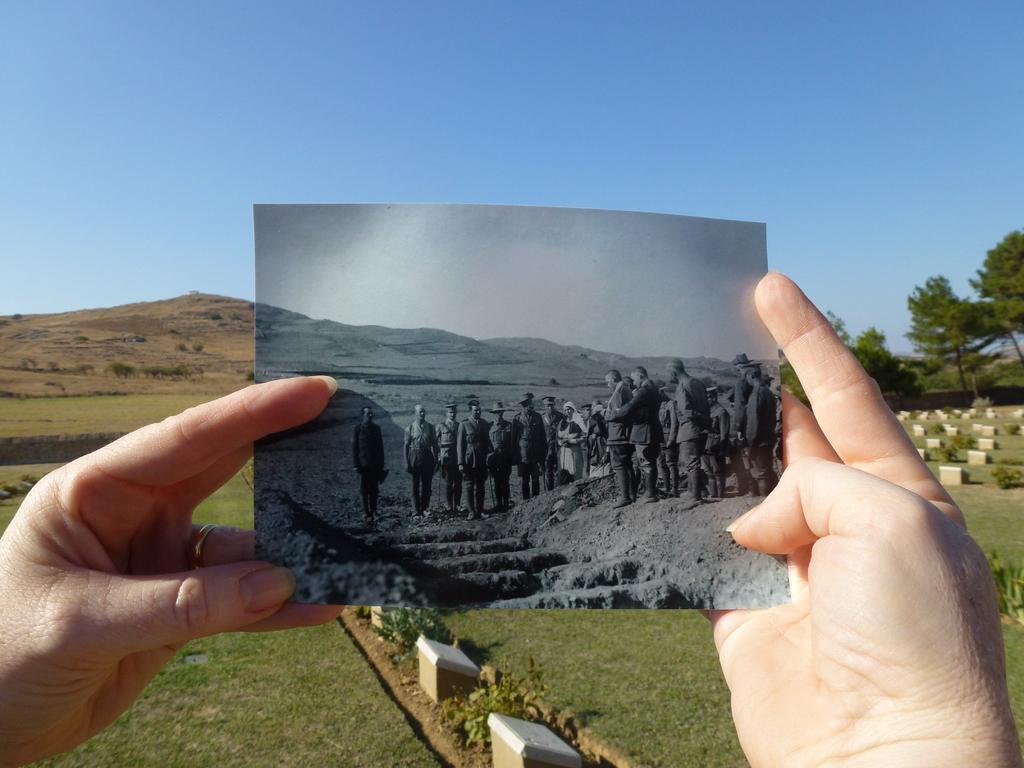Can you describe this image briefly? In this image we can see the hands of a person holding a photo. Here we can see a group of people in the photo. Here we can see the grass. Here we can see the trees on the right side. Here we can see the gravestones on the right side. 